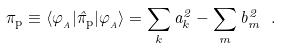<formula> <loc_0><loc_0><loc_500><loc_500>\pi _ { \text {p} } \equiv \langle \varphi _ { _ { A } } | \hat { \pi } _ { \text {p} } | \varphi _ { _ { A } } \rangle = \sum _ { k } a _ { k } ^ { 2 } - \sum _ { m } b _ { m } ^ { 2 } \ .</formula> 